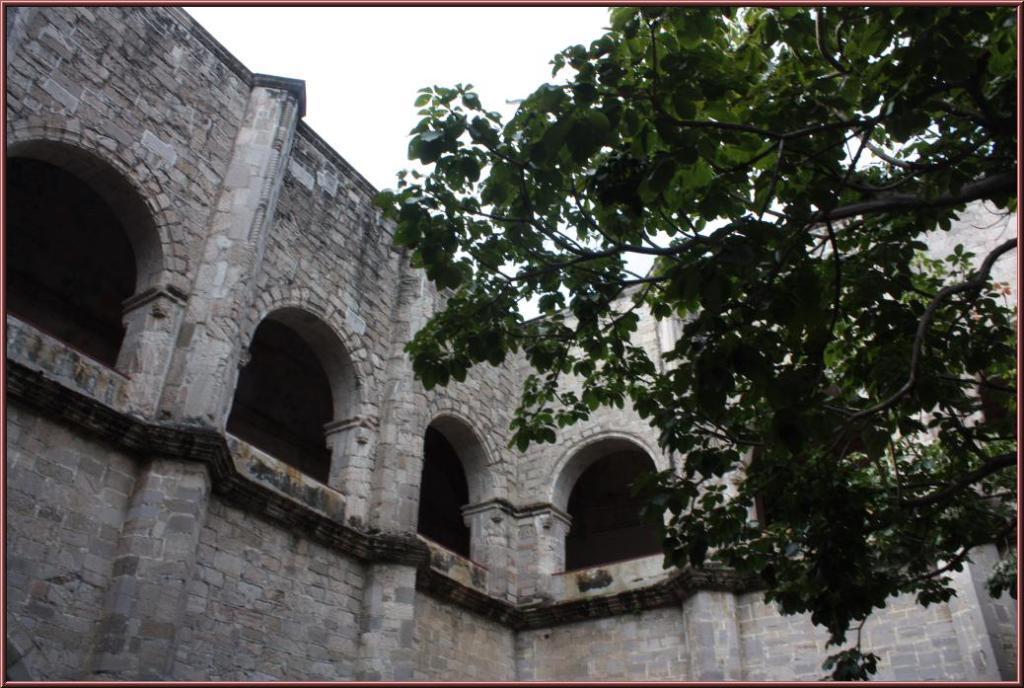In one or two sentences, can you explain what this image depicts? In this image in the front there is a tree. In the background there is a building and the sky is cloudy. 